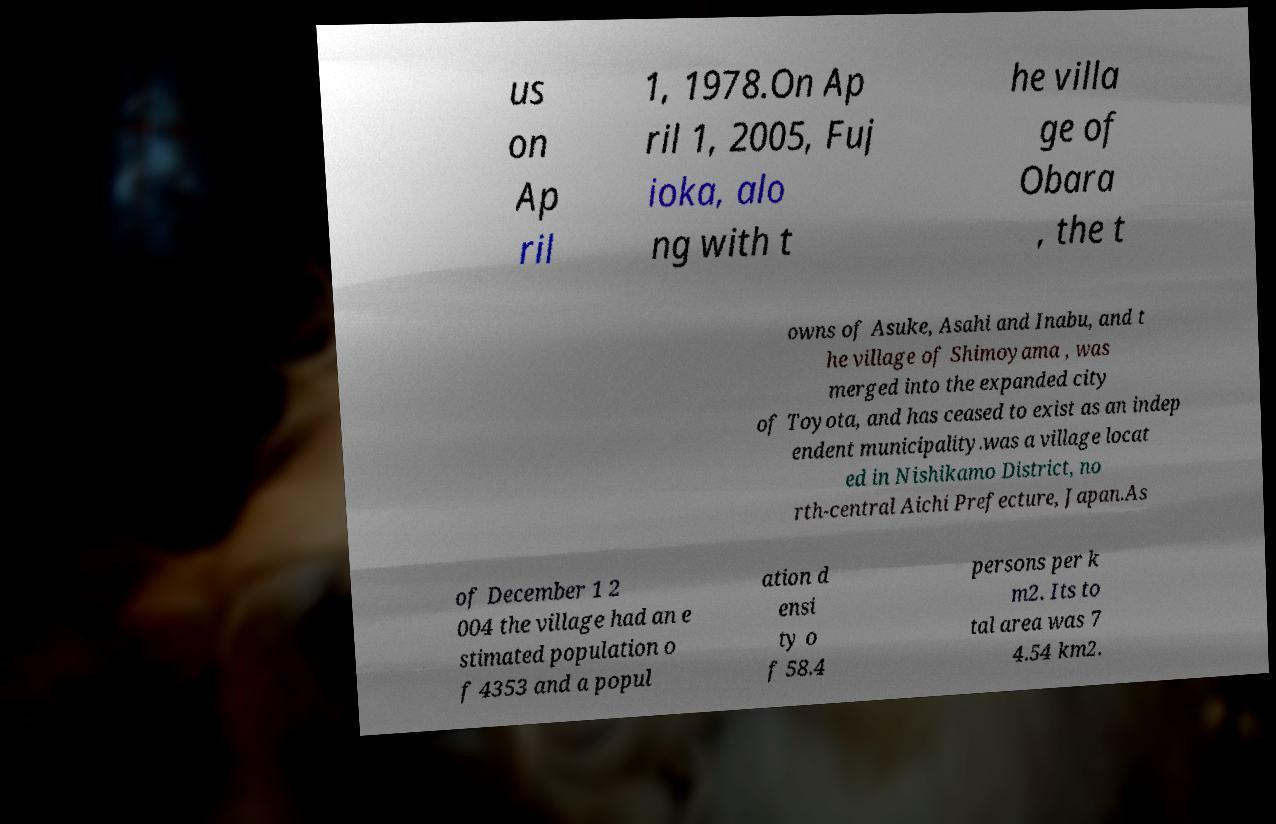For documentation purposes, I need the text within this image transcribed. Could you provide that? us on Ap ril 1, 1978.On Ap ril 1, 2005, Fuj ioka, alo ng with t he villa ge of Obara , the t owns of Asuke, Asahi and Inabu, and t he village of Shimoyama , was merged into the expanded city of Toyota, and has ceased to exist as an indep endent municipality.was a village locat ed in Nishikamo District, no rth-central Aichi Prefecture, Japan.As of December 1 2 004 the village had an e stimated population o f 4353 and a popul ation d ensi ty o f 58.4 persons per k m2. Its to tal area was 7 4.54 km2. 